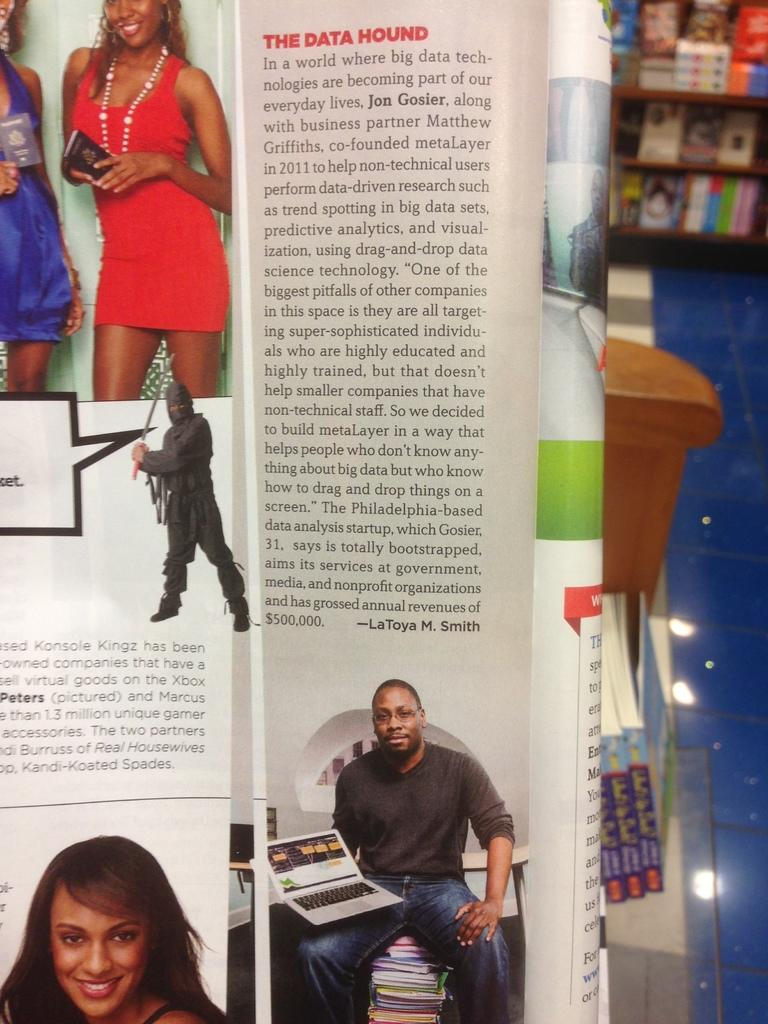What is the main object in the foreground of the image? There is a book folded in the foreground of the image. What can be seen on the glass in the background? There are books on the glass in the background. What is the location of the books on the floor? There are books on the floor in the background. Where are the books stored in the background? There are books in a shelf in the background. What type of nest can be seen in the image? There is no nest present in the image; it features books in various locations. 